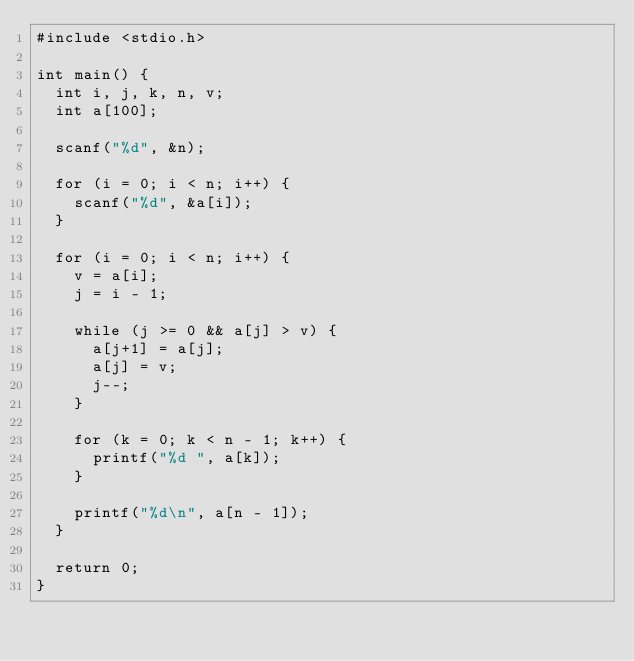<code> <loc_0><loc_0><loc_500><loc_500><_C_>#include <stdio.h>

int main() {
	int i, j, k, n, v;
	int a[100];

	scanf("%d", &n);

	for (i = 0; i < n; i++) {
		scanf("%d", &a[i]);
	}

	for (i = 0; i < n; i++) {
		v = a[i];
		j = i - 1;

		while (j >= 0 && a[j] > v) {
			a[j+1] = a[j];
			a[j] = v;
			j--;
		}

		for (k = 0; k < n - 1; k++) {
			printf("%d ", a[k]);
		}

		printf("%d\n", a[n - 1]);
	}

	return 0;
}</code> 